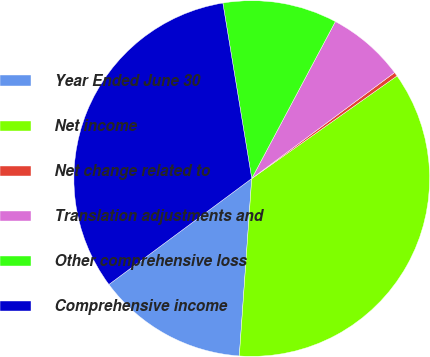Convert chart to OTSL. <chart><loc_0><loc_0><loc_500><loc_500><pie_chart><fcel>Year Ended June 30<fcel>Net income<fcel>Net change related to<fcel>Translation adjustments and<fcel>Other comprehensive loss<fcel>Comprehensive income<nl><fcel>13.73%<fcel>35.9%<fcel>0.37%<fcel>7.05%<fcel>10.39%<fcel>32.56%<nl></chart> 